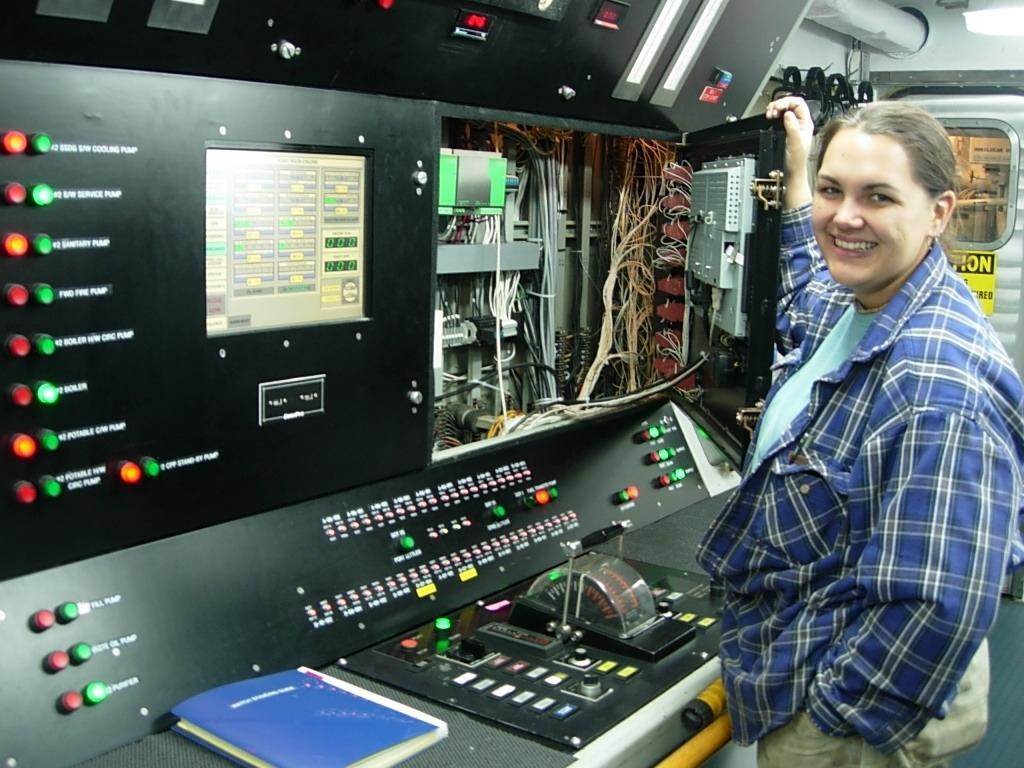Describe this image in one or two sentences. In this image I see the machine over here and I see many wires and I see a woman over here who is standing and I see that she is smiling. In the background I see the road on which there is something written and I see a book over here. 